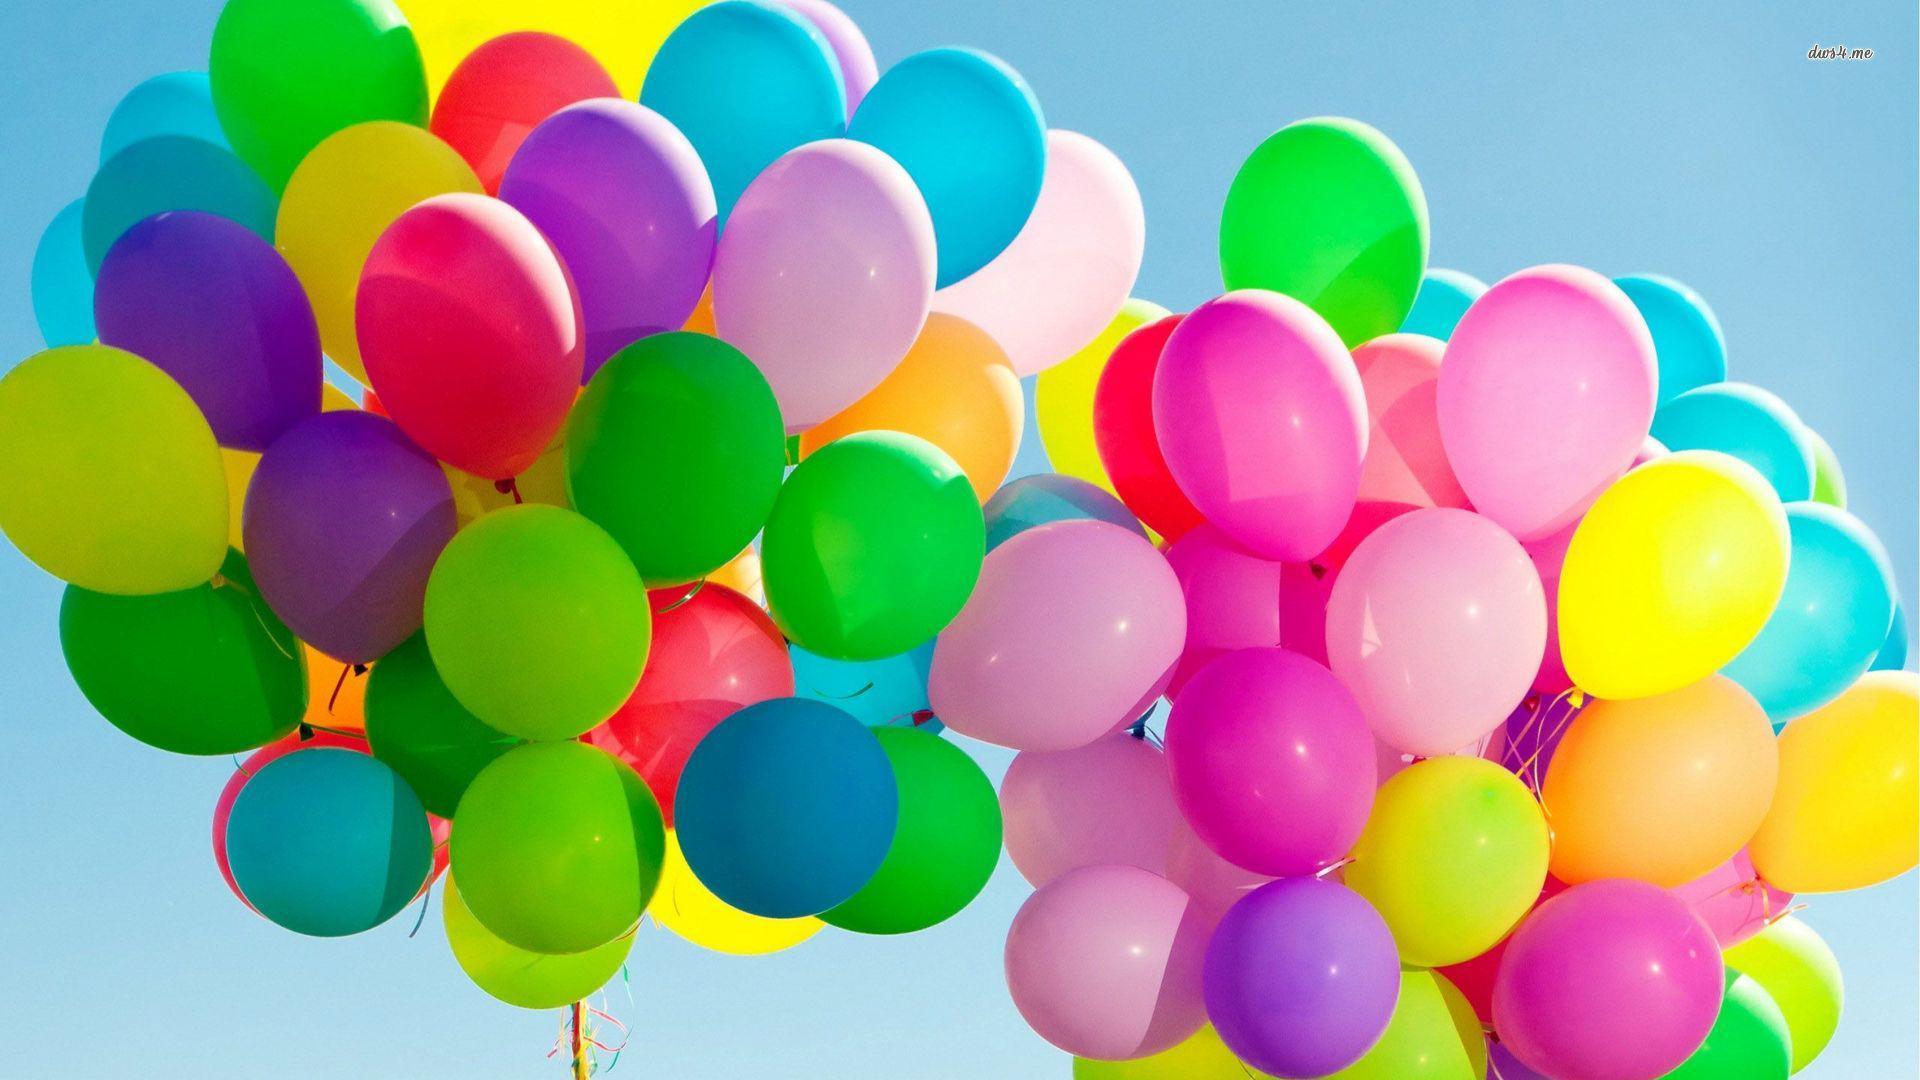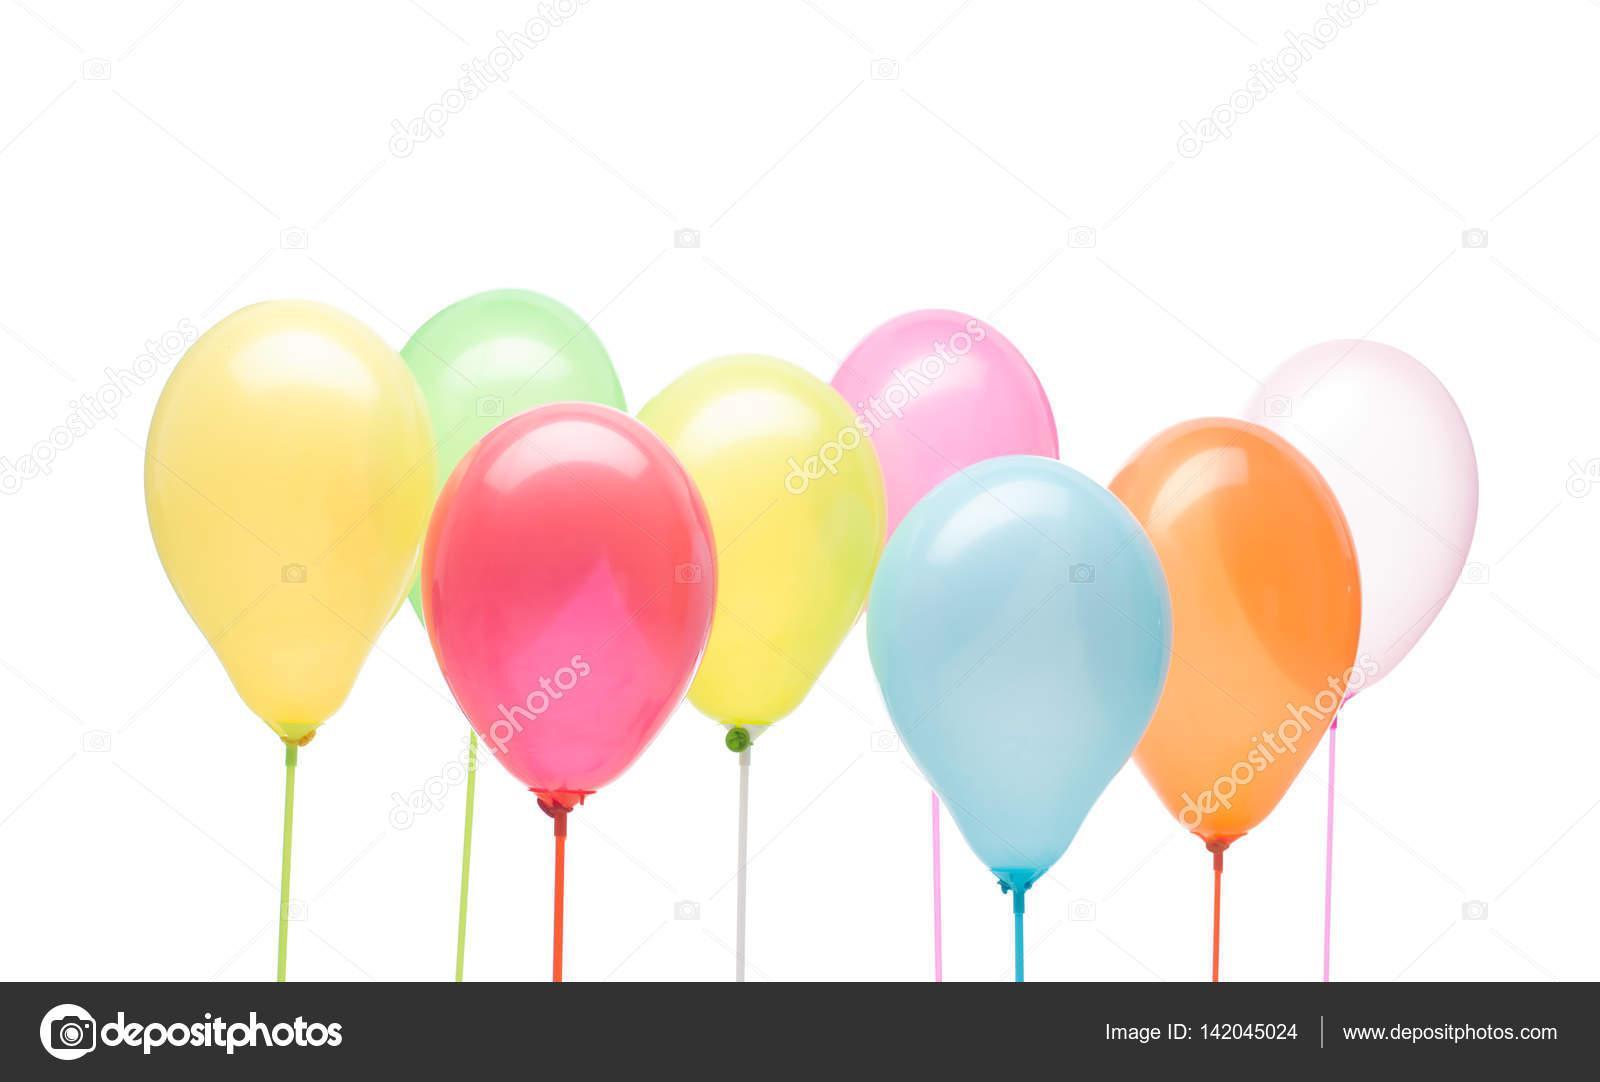The first image is the image on the left, the second image is the image on the right. Analyze the images presented: Is the assertion "In at least one image there are eight balloon with strings on them." valid? Answer yes or no. Yes. The first image is the image on the left, the second image is the image on the right. Analyze the images presented: Is the assertion "The right image contains eight or less balloons, while the left image contains more." valid? Answer yes or no. Yes. 